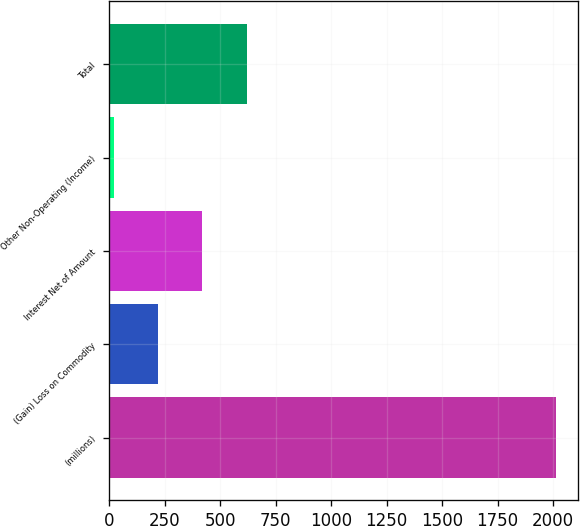<chart> <loc_0><loc_0><loc_500><loc_500><bar_chart><fcel>(millions)<fcel>(Gain) Loss on Commodity<fcel>Interest Net of Amount<fcel>Other Non-Operating (Income)<fcel>Total<nl><fcel>2013<fcel>220.2<fcel>419.4<fcel>21<fcel>618.6<nl></chart> 